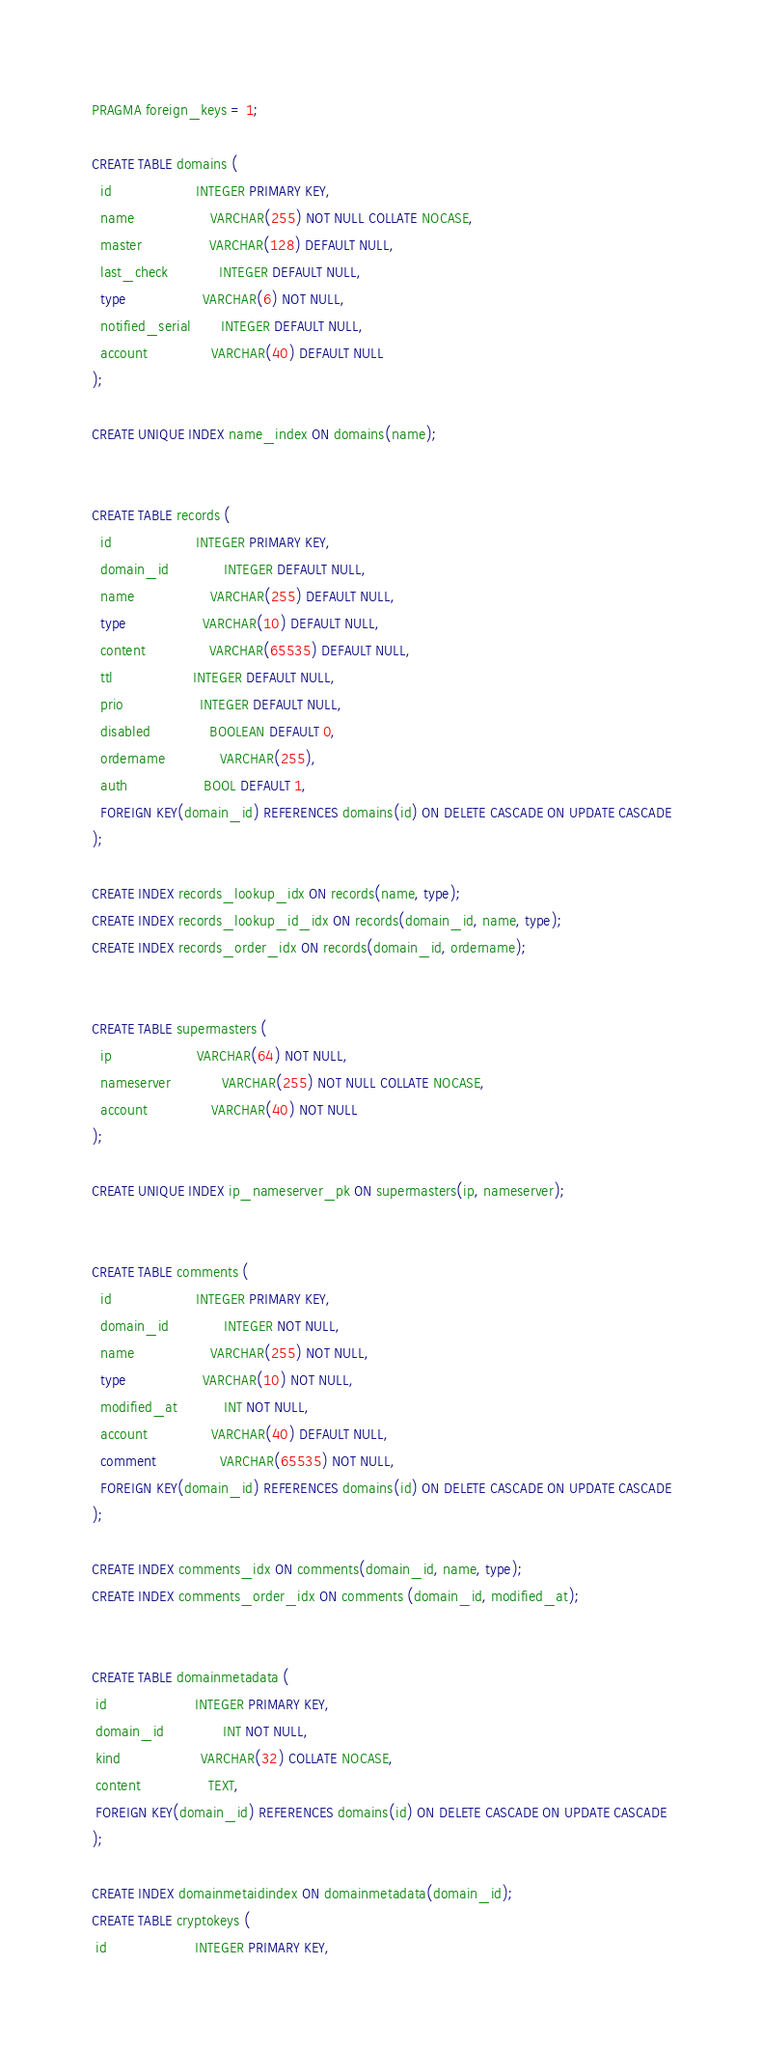<code> <loc_0><loc_0><loc_500><loc_500><_SQL_>PRAGMA foreign_keys = 1;

CREATE TABLE domains (
  id                    INTEGER PRIMARY KEY,
  name                  VARCHAR(255) NOT NULL COLLATE NOCASE,
  master                VARCHAR(128) DEFAULT NULL,
  last_check            INTEGER DEFAULT NULL,
  type                  VARCHAR(6) NOT NULL,
  notified_serial       INTEGER DEFAULT NULL,
  account               VARCHAR(40) DEFAULT NULL
);

CREATE UNIQUE INDEX name_index ON domains(name);


CREATE TABLE records (
  id                    INTEGER PRIMARY KEY,
  domain_id             INTEGER DEFAULT NULL,
  name                  VARCHAR(255) DEFAULT NULL,
  type                  VARCHAR(10) DEFAULT NULL,
  content               VARCHAR(65535) DEFAULT NULL,
  ttl                   INTEGER DEFAULT NULL,
  prio                  INTEGER DEFAULT NULL,
  disabled              BOOLEAN DEFAULT 0,
  ordername             VARCHAR(255),
  auth                  BOOL DEFAULT 1,
  FOREIGN KEY(domain_id) REFERENCES domains(id) ON DELETE CASCADE ON UPDATE CASCADE
);

CREATE INDEX records_lookup_idx ON records(name, type);
CREATE INDEX records_lookup_id_idx ON records(domain_id, name, type);
CREATE INDEX records_order_idx ON records(domain_id, ordername);


CREATE TABLE supermasters (
  ip                    VARCHAR(64) NOT NULL,
  nameserver            VARCHAR(255) NOT NULL COLLATE NOCASE,
  account               VARCHAR(40) NOT NULL
);

CREATE UNIQUE INDEX ip_nameserver_pk ON supermasters(ip, nameserver);


CREATE TABLE comments (
  id                    INTEGER PRIMARY KEY,
  domain_id             INTEGER NOT NULL,
  name                  VARCHAR(255) NOT NULL,
  type                  VARCHAR(10) NOT NULL,
  modified_at           INT NOT NULL,
  account               VARCHAR(40) DEFAULT NULL,
  comment               VARCHAR(65535) NOT NULL,
  FOREIGN KEY(domain_id) REFERENCES domains(id) ON DELETE CASCADE ON UPDATE CASCADE
);

CREATE INDEX comments_idx ON comments(domain_id, name, type);
CREATE INDEX comments_order_idx ON comments (domain_id, modified_at);


CREATE TABLE domainmetadata (
 id                     INTEGER PRIMARY KEY,
 domain_id              INT NOT NULL,
 kind                   VARCHAR(32) COLLATE NOCASE,
 content                TEXT,
 FOREIGN KEY(domain_id) REFERENCES domains(id) ON DELETE CASCADE ON UPDATE CASCADE
);

CREATE INDEX domainmetaidindex ON domainmetadata(domain_id);
CREATE TABLE cryptokeys (
 id                     INTEGER PRIMARY KEY,</code> 